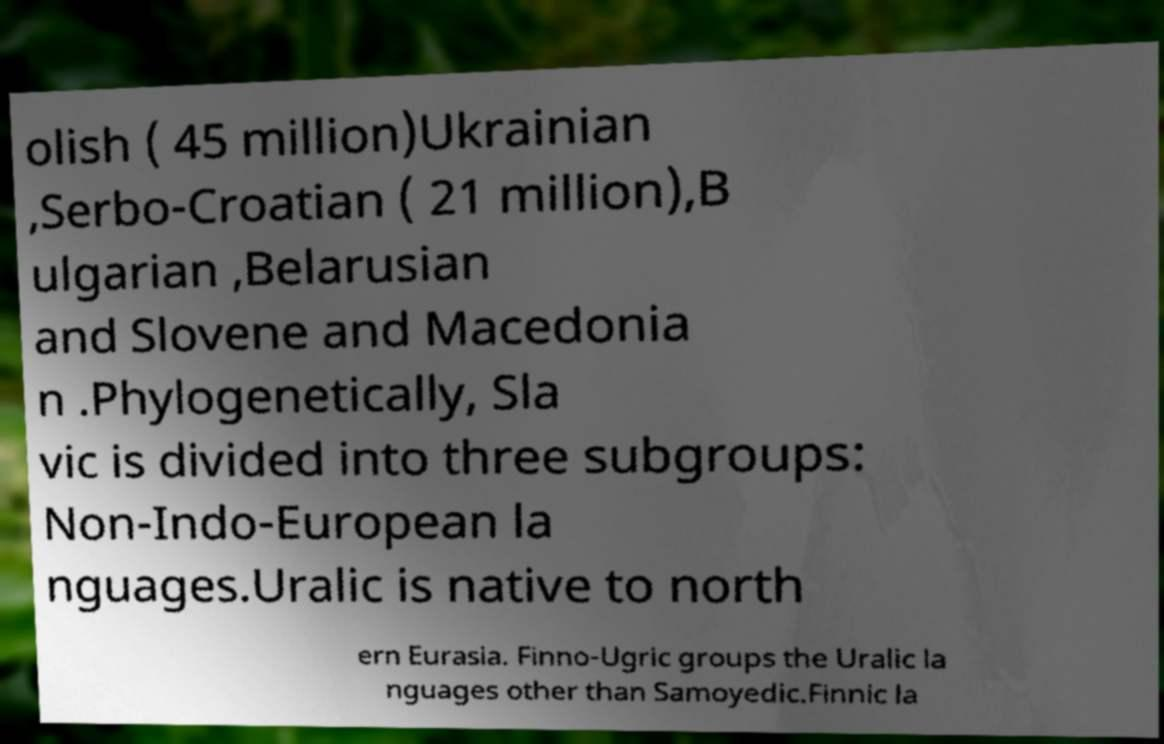Could you assist in decoding the text presented in this image and type it out clearly? olish ( 45 million)Ukrainian ,Serbo-Croatian ( 21 million),B ulgarian ,Belarusian and Slovene and Macedonia n .Phylogenetically, Sla vic is divided into three subgroups: Non-Indo-European la nguages.Uralic is native to north ern Eurasia. Finno-Ugric groups the Uralic la nguages other than Samoyedic.Finnic la 